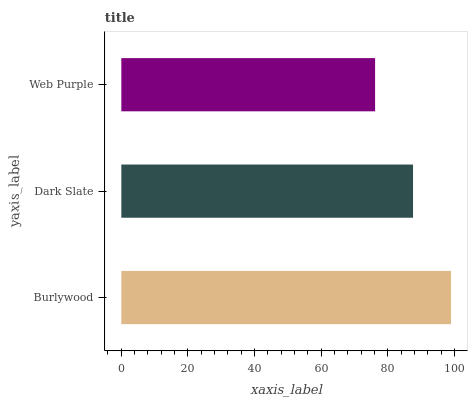Is Web Purple the minimum?
Answer yes or no. Yes. Is Burlywood the maximum?
Answer yes or no. Yes. Is Dark Slate the minimum?
Answer yes or no. No. Is Dark Slate the maximum?
Answer yes or no. No. Is Burlywood greater than Dark Slate?
Answer yes or no. Yes. Is Dark Slate less than Burlywood?
Answer yes or no. Yes. Is Dark Slate greater than Burlywood?
Answer yes or no. No. Is Burlywood less than Dark Slate?
Answer yes or no. No. Is Dark Slate the high median?
Answer yes or no. Yes. Is Dark Slate the low median?
Answer yes or no. Yes. Is Web Purple the high median?
Answer yes or no. No. Is Web Purple the low median?
Answer yes or no. No. 